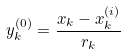Convert formula to latex. <formula><loc_0><loc_0><loc_500><loc_500>y _ { k } ^ { ( 0 ) } = \frac { x _ { k } - x _ { k } ^ { ( i ) } } { r _ { k } }</formula> 